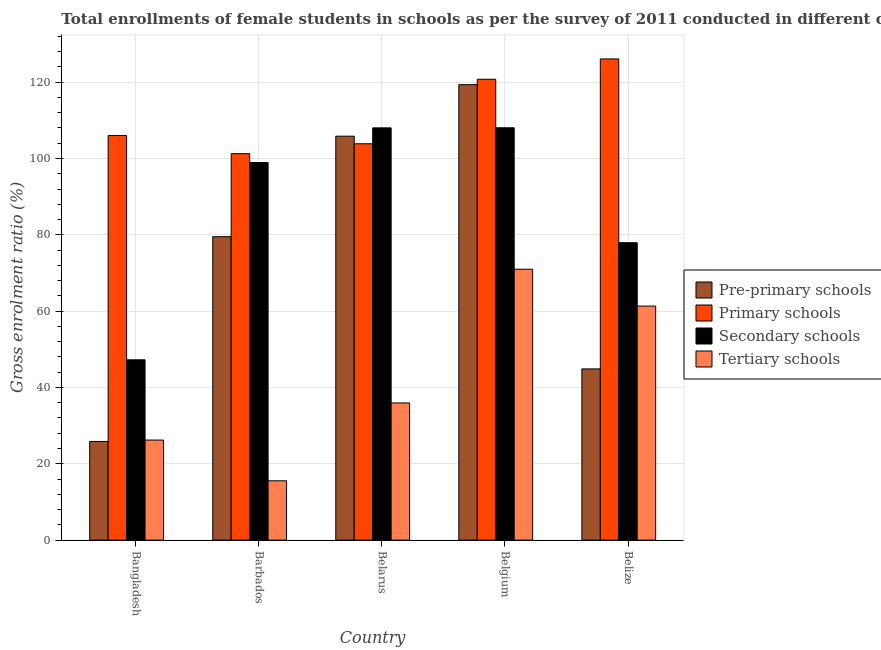Are the number of bars per tick equal to the number of legend labels?
Ensure brevity in your answer.  Yes. What is the label of the 5th group of bars from the left?
Provide a short and direct response. Belize. In how many cases, is the number of bars for a given country not equal to the number of legend labels?
Offer a terse response. 0. What is the gross enrolment ratio(female) in pre-primary schools in Bangladesh?
Give a very brief answer. 25.85. Across all countries, what is the maximum gross enrolment ratio(female) in pre-primary schools?
Keep it short and to the point. 119.34. Across all countries, what is the minimum gross enrolment ratio(female) in tertiary schools?
Provide a succinct answer. 15.54. In which country was the gross enrolment ratio(female) in tertiary schools minimum?
Offer a very short reply. Barbados. What is the total gross enrolment ratio(female) in tertiary schools in the graph?
Provide a succinct answer. 210. What is the difference between the gross enrolment ratio(female) in secondary schools in Barbados and that in Belarus?
Your answer should be very brief. -9.07. What is the difference between the gross enrolment ratio(female) in tertiary schools in Bangladesh and the gross enrolment ratio(female) in pre-primary schools in Belarus?
Your response must be concise. -79.63. What is the average gross enrolment ratio(female) in pre-primary schools per country?
Provide a succinct answer. 75.08. What is the difference between the gross enrolment ratio(female) in tertiary schools and gross enrolment ratio(female) in pre-primary schools in Bangladesh?
Keep it short and to the point. 0.36. What is the ratio of the gross enrolment ratio(female) in secondary schools in Belarus to that in Belgium?
Your response must be concise. 1. What is the difference between the highest and the second highest gross enrolment ratio(female) in tertiary schools?
Your answer should be compact. 9.65. What is the difference between the highest and the lowest gross enrolment ratio(female) in secondary schools?
Offer a very short reply. 60.81. In how many countries, is the gross enrolment ratio(female) in secondary schools greater than the average gross enrolment ratio(female) in secondary schools taken over all countries?
Give a very brief answer. 3. Is the sum of the gross enrolment ratio(female) in tertiary schools in Bangladesh and Belize greater than the maximum gross enrolment ratio(female) in secondary schools across all countries?
Give a very brief answer. No. Is it the case that in every country, the sum of the gross enrolment ratio(female) in pre-primary schools and gross enrolment ratio(female) in primary schools is greater than the sum of gross enrolment ratio(female) in tertiary schools and gross enrolment ratio(female) in secondary schools?
Offer a very short reply. No. What does the 4th bar from the left in Belarus represents?
Offer a terse response. Tertiary schools. What does the 3rd bar from the right in Barbados represents?
Provide a short and direct response. Primary schools. How many bars are there?
Provide a succinct answer. 20. Are all the bars in the graph horizontal?
Your response must be concise. No. What is the difference between two consecutive major ticks on the Y-axis?
Offer a very short reply. 20. How are the legend labels stacked?
Keep it short and to the point. Vertical. What is the title of the graph?
Give a very brief answer. Total enrollments of female students in schools as per the survey of 2011 conducted in different countries. What is the label or title of the X-axis?
Offer a terse response. Country. What is the Gross enrolment ratio (%) in Pre-primary schools in Bangladesh?
Make the answer very short. 25.85. What is the Gross enrolment ratio (%) of Primary schools in Bangladesh?
Your response must be concise. 106.02. What is the Gross enrolment ratio (%) in Secondary schools in Bangladesh?
Ensure brevity in your answer.  47.24. What is the Gross enrolment ratio (%) of Tertiary schools in Bangladesh?
Make the answer very short. 26.21. What is the Gross enrolment ratio (%) in Pre-primary schools in Barbados?
Ensure brevity in your answer.  79.51. What is the Gross enrolment ratio (%) in Primary schools in Barbados?
Your response must be concise. 101.26. What is the Gross enrolment ratio (%) of Secondary schools in Barbados?
Ensure brevity in your answer.  98.95. What is the Gross enrolment ratio (%) of Tertiary schools in Barbados?
Your answer should be very brief. 15.54. What is the Gross enrolment ratio (%) of Pre-primary schools in Belarus?
Your answer should be very brief. 105.85. What is the Gross enrolment ratio (%) of Primary schools in Belarus?
Ensure brevity in your answer.  103.86. What is the Gross enrolment ratio (%) of Secondary schools in Belarus?
Offer a terse response. 108.02. What is the Gross enrolment ratio (%) in Tertiary schools in Belarus?
Provide a succinct answer. 35.94. What is the Gross enrolment ratio (%) of Pre-primary schools in Belgium?
Offer a terse response. 119.34. What is the Gross enrolment ratio (%) in Primary schools in Belgium?
Provide a succinct answer. 120.76. What is the Gross enrolment ratio (%) of Secondary schools in Belgium?
Keep it short and to the point. 108.05. What is the Gross enrolment ratio (%) in Tertiary schools in Belgium?
Provide a short and direct response. 70.98. What is the Gross enrolment ratio (%) in Pre-primary schools in Belize?
Make the answer very short. 44.86. What is the Gross enrolment ratio (%) in Primary schools in Belize?
Provide a short and direct response. 126.09. What is the Gross enrolment ratio (%) of Secondary schools in Belize?
Offer a very short reply. 77.93. What is the Gross enrolment ratio (%) of Tertiary schools in Belize?
Make the answer very short. 61.33. Across all countries, what is the maximum Gross enrolment ratio (%) of Pre-primary schools?
Offer a very short reply. 119.34. Across all countries, what is the maximum Gross enrolment ratio (%) of Primary schools?
Provide a short and direct response. 126.09. Across all countries, what is the maximum Gross enrolment ratio (%) in Secondary schools?
Provide a short and direct response. 108.05. Across all countries, what is the maximum Gross enrolment ratio (%) of Tertiary schools?
Keep it short and to the point. 70.98. Across all countries, what is the minimum Gross enrolment ratio (%) of Pre-primary schools?
Provide a short and direct response. 25.85. Across all countries, what is the minimum Gross enrolment ratio (%) of Primary schools?
Your answer should be compact. 101.26. Across all countries, what is the minimum Gross enrolment ratio (%) in Secondary schools?
Make the answer very short. 47.24. Across all countries, what is the minimum Gross enrolment ratio (%) in Tertiary schools?
Your response must be concise. 15.54. What is the total Gross enrolment ratio (%) in Pre-primary schools in the graph?
Ensure brevity in your answer.  375.41. What is the total Gross enrolment ratio (%) in Primary schools in the graph?
Offer a very short reply. 557.98. What is the total Gross enrolment ratio (%) of Secondary schools in the graph?
Offer a terse response. 440.19. What is the total Gross enrolment ratio (%) in Tertiary schools in the graph?
Your answer should be compact. 210. What is the difference between the Gross enrolment ratio (%) in Pre-primary schools in Bangladesh and that in Barbados?
Give a very brief answer. -53.65. What is the difference between the Gross enrolment ratio (%) in Primary schools in Bangladesh and that in Barbados?
Provide a short and direct response. 4.76. What is the difference between the Gross enrolment ratio (%) of Secondary schools in Bangladesh and that in Barbados?
Give a very brief answer. -51.71. What is the difference between the Gross enrolment ratio (%) in Tertiary schools in Bangladesh and that in Barbados?
Provide a short and direct response. 10.67. What is the difference between the Gross enrolment ratio (%) of Pre-primary schools in Bangladesh and that in Belarus?
Keep it short and to the point. -79.99. What is the difference between the Gross enrolment ratio (%) in Primary schools in Bangladesh and that in Belarus?
Offer a terse response. 2.16. What is the difference between the Gross enrolment ratio (%) of Secondary schools in Bangladesh and that in Belarus?
Offer a terse response. -60.78. What is the difference between the Gross enrolment ratio (%) of Tertiary schools in Bangladesh and that in Belarus?
Keep it short and to the point. -9.73. What is the difference between the Gross enrolment ratio (%) in Pre-primary schools in Bangladesh and that in Belgium?
Your answer should be very brief. -93.49. What is the difference between the Gross enrolment ratio (%) in Primary schools in Bangladesh and that in Belgium?
Provide a succinct answer. -14.75. What is the difference between the Gross enrolment ratio (%) in Secondary schools in Bangladesh and that in Belgium?
Provide a succinct answer. -60.8. What is the difference between the Gross enrolment ratio (%) in Tertiary schools in Bangladesh and that in Belgium?
Your response must be concise. -44.77. What is the difference between the Gross enrolment ratio (%) of Pre-primary schools in Bangladesh and that in Belize?
Give a very brief answer. -19.01. What is the difference between the Gross enrolment ratio (%) in Primary schools in Bangladesh and that in Belize?
Provide a succinct answer. -20.07. What is the difference between the Gross enrolment ratio (%) of Secondary schools in Bangladesh and that in Belize?
Offer a very short reply. -30.68. What is the difference between the Gross enrolment ratio (%) in Tertiary schools in Bangladesh and that in Belize?
Provide a succinct answer. -35.11. What is the difference between the Gross enrolment ratio (%) of Pre-primary schools in Barbados and that in Belarus?
Make the answer very short. -26.34. What is the difference between the Gross enrolment ratio (%) of Primary schools in Barbados and that in Belarus?
Offer a very short reply. -2.59. What is the difference between the Gross enrolment ratio (%) of Secondary schools in Barbados and that in Belarus?
Your answer should be very brief. -9.07. What is the difference between the Gross enrolment ratio (%) of Tertiary schools in Barbados and that in Belarus?
Offer a terse response. -20.4. What is the difference between the Gross enrolment ratio (%) in Pre-primary schools in Barbados and that in Belgium?
Keep it short and to the point. -39.84. What is the difference between the Gross enrolment ratio (%) in Primary schools in Barbados and that in Belgium?
Make the answer very short. -19.5. What is the difference between the Gross enrolment ratio (%) in Secondary schools in Barbados and that in Belgium?
Provide a succinct answer. -9.1. What is the difference between the Gross enrolment ratio (%) of Tertiary schools in Barbados and that in Belgium?
Ensure brevity in your answer.  -55.44. What is the difference between the Gross enrolment ratio (%) in Pre-primary schools in Barbados and that in Belize?
Ensure brevity in your answer.  34.65. What is the difference between the Gross enrolment ratio (%) in Primary schools in Barbados and that in Belize?
Your answer should be very brief. -24.82. What is the difference between the Gross enrolment ratio (%) in Secondary schools in Barbados and that in Belize?
Ensure brevity in your answer.  21.02. What is the difference between the Gross enrolment ratio (%) in Tertiary schools in Barbados and that in Belize?
Keep it short and to the point. -45.79. What is the difference between the Gross enrolment ratio (%) of Pre-primary schools in Belarus and that in Belgium?
Your answer should be compact. -13.5. What is the difference between the Gross enrolment ratio (%) of Primary schools in Belarus and that in Belgium?
Give a very brief answer. -16.91. What is the difference between the Gross enrolment ratio (%) in Secondary schools in Belarus and that in Belgium?
Your response must be concise. -0.02. What is the difference between the Gross enrolment ratio (%) of Tertiary schools in Belarus and that in Belgium?
Provide a succinct answer. -35.04. What is the difference between the Gross enrolment ratio (%) in Pre-primary schools in Belarus and that in Belize?
Your response must be concise. 60.99. What is the difference between the Gross enrolment ratio (%) in Primary schools in Belarus and that in Belize?
Give a very brief answer. -22.23. What is the difference between the Gross enrolment ratio (%) in Secondary schools in Belarus and that in Belize?
Your answer should be very brief. 30.1. What is the difference between the Gross enrolment ratio (%) of Tertiary schools in Belarus and that in Belize?
Keep it short and to the point. -25.39. What is the difference between the Gross enrolment ratio (%) of Pre-primary schools in Belgium and that in Belize?
Ensure brevity in your answer.  74.48. What is the difference between the Gross enrolment ratio (%) of Primary schools in Belgium and that in Belize?
Offer a terse response. -5.32. What is the difference between the Gross enrolment ratio (%) in Secondary schools in Belgium and that in Belize?
Provide a succinct answer. 30.12. What is the difference between the Gross enrolment ratio (%) of Tertiary schools in Belgium and that in Belize?
Make the answer very short. 9.65. What is the difference between the Gross enrolment ratio (%) in Pre-primary schools in Bangladesh and the Gross enrolment ratio (%) in Primary schools in Barbados?
Your answer should be compact. -75.41. What is the difference between the Gross enrolment ratio (%) of Pre-primary schools in Bangladesh and the Gross enrolment ratio (%) of Secondary schools in Barbados?
Ensure brevity in your answer.  -73.1. What is the difference between the Gross enrolment ratio (%) in Pre-primary schools in Bangladesh and the Gross enrolment ratio (%) in Tertiary schools in Barbados?
Offer a terse response. 10.31. What is the difference between the Gross enrolment ratio (%) in Primary schools in Bangladesh and the Gross enrolment ratio (%) in Secondary schools in Barbados?
Offer a very short reply. 7.07. What is the difference between the Gross enrolment ratio (%) in Primary schools in Bangladesh and the Gross enrolment ratio (%) in Tertiary schools in Barbados?
Keep it short and to the point. 90.48. What is the difference between the Gross enrolment ratio (%) in Secondary schools in Bangladesh and the Gross enrolment ratio (%) in Tertiary schools in Barbados?
Your answer should be very brief. 31.7. What is the difference between the Gross enrolment ratio (%) in Pre-primary schools in Bangladesh and the Gross enrolment ratio (%) in Primary schools in Belarus?
Ensure brevity in your answer.  -78. What is the difference between the Gross enrolment ratio (%) of Pre-primary schools in Bangladesh and the Gross enrolment ratio (%) of Secondary schools in Belarus?
Offer a terse response. -82.17. What is the difference between the Gross enrolment ratio (%) in Pre-primary schools in Bangladesh and the Gross enrolment ratio (%) in Tertiary schools in Belarus?
Your answer should be compact. -10.09. What is the difference between the Gross enrolment ratio (%) of Primary schools in Bangladesh and the Gross enrolment ratio (%) of Secondary schools in Belarus?
Your response must be concise. -2.01. What is the difference between the Gross enrolment ratio (%) in Primary schools in Bangladesh and the Gross enrolment ratio (%) in Tertiary schools in Belarus?
Give a very brief answer. 70.08. What is the difference between the Gross enrolment ratio (%) of Secondary schools in Bangladesh and the Gross enrolment ratio (%) of Tertiary schools in Belarus?
Ensure brevity in your answer.  11.3. What is the difference between the Gross enrolment ratio (%) of Pre-primary schools in Bangladesh and the Gross enrolment ratio (%) of Primary schools in Belgium?
Provide a succinct answer. -94.91. What is the difference between the Gross enrolment ratio (%) of Pre-primary schools in Bangladesh and the Gross enrolment ratio (%) of Secondary schools in Belgium?
Your response must be concise. -82.2. What is the difference between the Gross enrolment ratio (%) of Pre-primary schools in Bangladesh and the Gross enrolment ratio (%) of Tertiary schools in Belgium?
Give a very brief answer. -45.13. What is the difference between the Gross enrolment ratio (%) in Primary schools in Bangladesh and the Gross enrolment ratio (%) in Secondary schools in Belgium?
Keep it short and to the point. -2.03. What is the difference between the Gross enrolment ratio (%) of Primary schools in Bangladesh and the Gross enrolment ratio (%) of Tertiary schools in Belgium?
Ensure brevity in your answer.  35.04. What is the difference between the Gross enrolment ratio (%) of Secondary schools in Bangladesh and the Gross enrolment ratio (%) of Tertiary schools in Belgium?
Your response must be concise. -23.74. What is the difference between the Gross enrolment ratio (%) of Pre-primary schools in Bangladesh and the Gross enrolment ratio (%) of Primary schools in Belize?
Offer a very short reply. -100.23. What is the difference between the Gross enrolment ratio (%) of Pre-primary schools in Bangladesh and the Gross enrolment ratio (%) of Secondary schools in Belize?
Ensure brevity in your answer.  -52.07. What is the difference between the Gross enrolment ratio (%) of Pre-primary schools in Bangladesh and the Gross enrolment ratio (%) of Tertiary schools in Belize?
Provide a succinct answer. -35.47. What is the difference between the Gross enrolment ratio (%) in Primary schools in Bangladesh and the Gross enrolment ratio (%) in Secondary schools in Belize?
Your response must be concise. 28.09. What is the difference between the Gross enrolment ratio (%) in Primary schools in Bangladesh and the Gross enrolment ratio (%) in Tertiary schools in Belize?
Offer a very short reply. 44.69. What is the difference between the Gross enrolment ratio (%) of Secondary schools in Bangladesh and the Gross enrolment ratio (%) of Tertiary schools in Belize?
Give a very brief answer. -14.08. What is the difference between the Gross enrolment ratio (%) in Pre-primary schools in Barbados and the Gross enrolment ratio (%) in Primary schools in Belarus?
Provide a short and direct response. -24.35. What is the difference between the Gross enrolment ratio (%) in Pre-primary schools in Barbados and the Gross enrolment ratio (%) in Secondary schools in Belarus?
Provide a short and direct response. -28.52. What is the difference between the Gross enrolment ratio (%) in Pre-primary schools in Barbados and the Gross enrolment ratio (%) in Tertiary schools in Belarus?
Provide a short and direct response. 43.57. What is the difference between the Gross enrolment ratio (%) of Primary schools in Barbados and the Gross enrolment ratio (%) of Secondary schools in Belarus?
Provide a short and direct response. -6.76. What is the difference between the Gross enrolment ratio (%) of Primary schools in Barbados and the Gross enrolment ratio (%) of Tertiary schools in Belarus?
Provide a succinct answer. 65.32. What is the difference between the Gross enrolment ratio (%) in Secondary schools in Barbados and the Gross enrolment ratio (%) in Tertiary schools in Belarus?
Keep it short and to the point. 63.01. What is the difference between the Gross enrolment ratio (%) of Pre-primary schools in Barbados and the Gross enrolment ratio (%) of Primary schools in Belgium?
Provide a short and direct response. -41.26. What is the difference between the Gross enrolment ratio (%) of Pre-primary schools in Barbados and the Gross enrolment ratio (%) of Secondary schools in Belgium?
Your answer should be compact. -28.54. What is the difference between the Gross enrolment ratio (%) in Pre-primary schools in Barbados and the Gross enrolment ratio (%) in Tertiary schools in Belgium?
Your answer should be compact. 8.53. What is the difference between the Gross enrolment ratio (%) of Primary schools in Barbados and the Gross enrolment ratio (%) of Secondary schools in Belgium?
Give a very brief answer. -6.79. What is the difference between the Gross enrolment ratio (%) in Primary schools in Barbados and the Gross enrolment ratio (%) in Tertiary schools in Belgium?
Your response must be concise. 30.28. What is the difference between the Gross enrolment ratio (%) of Secondary schools in Barbados and the Gross enrolment ratio (%) of Tertiary schools in Belgium?
Offer a terse response. 27.97. What is the difference between the Gross enrolment ratio (%) of Pre-primary schools in Barbados and the Gross enrolment ratio (%) of Primary schools in Belize?
Provide a short and direct response. -46.58. What is the difference between the Gross enrolment ratio (%) in Pre-primary schools in Barbados and the Gross enrolment ratio (%) in Secondary schools in Belize?
Give a very brief answer. 1.58. What is the difference between the Gross enrolment ratio (%) of Pre-primary schools in Barbados and the Gross enrolment ratio (%) of Tertiary schools in Belize?
Offer a very short reply. 18.18. What is the difference between the Gross enrolment ratio (%) in Primary schools in Barbados and the Gross enrolment ratio (%) in Secondary schools in Belize?
Your answer should be compact. 23.33. What is the difference between the Gross enrolment ratio (%) of Primary schools in Barbados and the Gross enrolment ratio (%) of Tertiary schools in Belize?
Offer a terse response. 39.94. What is the difference between the Gross enrolment ratio (%) in Secondary schools in Barbados and the Gross enrolment ratio (%) in Tertiary schools in Belize?
Your answer should be very brief. 37.62. What is the difference between the Gross enrolment ratio (%) in Pre-primary schools in Belarus and the Gross enrolment ratio (%) in Primary schools in Belgium?
Ensure brevity in your answer.  -14.92. What is the difference between the Gross enrolment ratio (%) in Pre-primary schools in Belarus and the Gross enrolment ratio (%) in Secondary schools in Belgium?
Make the answer very short. -2.2. What is the difference between the Gross enrolment ratio (%) in Pre-primary schools in Belarus and the Gross enrolment ratio (%) in Tertiary schools in Belgium?
Give a very brief answer. 34.87. What is the difference between the Gross enrolment ratio (%) of Primary schools in Belarus and the Gross enrolment ratio (%) of Secondary schools in Belgium?
Make the answer very short. -4.19. What is the difference between the Gross enrolment ratio (%) in Primary schools in Belarus and the Gross enrolment ratio (%) in Tertiary schools in Belgium?
Provide a short and direct response. 32.88. What is the difference between the Gross enrolment ratio (%) in Secondary schools in Belarus and the Gross enrolment ratio (%) in Tertiary schools in Belgium?
Offer a very short reply. 37.04. What is the difference between the Gross enrolment ratio (%) in Pre-primary schools in Belarus and the Gross enrolment ratio (%) in Primary schools in Belize?
Your answer should be very brief. -20.24. What is the difference between the Gross enrolment ratio (%) in Pre-primary schools in Belarus and the Gross enrolment ratio (%) in Secondary schools in Belize?
Ensure brevity in your answer.  27.92. What is the difference between the Gross enrolment ratio (%) of Pre-primary schools in Belarus and the Gross enrolment ratio (%) of Tertiary schools in Belize?
Provide a short and direct response. 44.52. What is the difference between the Gross enrolment ratio (%) in Primary schools in Belarus and the Gross enrolment ratio (%) in Secondary schools in Belize?
Ensure brevity in your answer.  25.93. What is the difference between the Gross enrolment ratio (%) of Primary schools in Belarus and the Gross enrolment ratio (%) of Tertiary schools in Belize?
Make the answer very short. 42.53. What is the difference between the Gross enrolment ratio (%) in Secondary schools in Belarus and the Gross enrolment ratio (%) in Tertiary schools in Belize?
Provide a short and direct response. 46.7. What is the difference between the Gross enrolment ratio (%) of Pre-primary schools in Belgium and the Gross enrolment ratio (%) of Primary schools in Belize?
Offer a terse response. -6.74. What is the difference between the Gross enrolment ratio (%) in Pre-primary schools in Belgium and the Gross enrolment ratio (%) in Secondary schools in Belize?
Offer a very short reply. 41.42. What is the difference between the Gross enrolment ratio (%) in Pre-primary schools in Belgium and the Gross enrolment ratio (%) in Tertiary schools in Belize?
Give a very brief answer. 58.02. What is the difference between the Gross enrolment ratio (%) in Primary schools in Belgium and the Gross enrolment ratio (%) in Secondary schools in Belize?
Ensure brevity in your answer.  42.84. What is the difference between the Gross enrolment ratio (%) of Primary schools in Belgium and the Gross enrolment ratio (%) of Tertiary schools in Belize?
Offer a terse response. 59.44. What is the difference between the Gross enrolment ratio (%) in Secondary schools in Belgium and the Gross enrolment ratio (%) in Tertiary schools in Belize?
Give a very brief answer. 46.72. What is the average Gross enrolment ratio (%) in Pre-primary schools per country?
Offer a terse response. 75.08. What is the average Gross enrolment ratio (%) of Primary schools per country?
Offer a very short reply. 111.6. What is the average Gross enrolment ratio (%) in Secondary schools per country?
Offer a very short reply. 88.04. What is the average Gross enrolment ratio (%) of Tertiary schools per country?
Ensure brevity in your answer.  42. What is the difference between the Gross enrolment ratio (%) of Pre-primary schools and Gross enrolment ratio (%) of Primary schools in Bangladesh?
Your answer should be compact. -80.16. What is the difference between the Gross enrolment ratio (%) of Pre-primary schools and Gross enrolment ratio (%) of Secondary schools in Bangladesh?
Make the answer very short. -21.39. What is the difference between the Gross enrolment ratio (%) in Pre-primary schools and Gross enrolment ratio (%) in Tertiary schools in Bangladesh?
Your answer should be compact. -0.36. What is the difference between the Gross enrolment ratio (%) of Primary schools and Gross enrolment ratio (%) of Secondary schools in Bangladesh?
Keep it short and to the point. 58.77. What is the difference between the Gross enrolment ratio (%) of Primary schools and Gross enrolment ratio (%) of Tertiary schools in Bangladesh?
Provide a short and direct response. 79.8. What is the difference between the Gross enrolment ratio (%) in Secondary schools and Gross enrolment ratio (%) in Tertiary schools in Bangladesh?
Offer a very short reply. 21.03. What is the difference between the Gross enrolment ratio (%) of Pre-primary schools and Gross enrolment ratio (%) of Primary schools in Barbados?
Provide a short and direct response. -21.75. What is the difference between the Gross enrolment ratio (%) of Pre-primary schools and Gross enrolment ratio (%) of Secondary schools in Barbados?
Keep it short and to the point. -19.44. What is the difference between the Gross enrolment ratio (%) in Pre-primary schools and Gross enrolment ratio (%) in Tertiary schools in Barbados?
Ensure brevity in your answer.  63.97. What is the difference between the Gross enrolment ratio (%) of Primary schools and Gross enrolment ratio (%) of Secondary schools in Barbados?
Give a very brief answer. 2.31. What is the difference between the Gross enrolment ratio (%) of Primary schools and Gross enrolment ratio (%) of Tertiary schools in Barbados?
Your answer should be compact. 85.72. What is the difference between the Gross enrolment ratio (%) in Secondary schools and Gross enrolment ratio (%) in Tertiary schools in Barbados?
Give a very brief answer. 83.41. What is the difference between the Gross enrolment ratio (%) of Pre-primary schools and Gross enrolment ratio (%) of Primary schools in Belarus?
Provide a succinct answer. 1.99. What is the difference between the Gross enrolment ratio (%) in Pre-primary schools and Gross enrolment ratio (%) in Secondary schools in Belarus?
Your response must be concise. -2.18. What is the difference between the Gross enrolment ratio (%) of Pre-primary schools and Gross enrolment ratio (%) of Tertiary schools in Belarus?
Your answer should be very brief. 69.91. What is the difference between the Gross enrolment ratio (%) of Primary schools and Gross enrolment ratio (%) of Secondary schools in Belarus?
Your answer should be compact. -4.17. What is the difference between the Gross enrolment ratio (%) of Primary schools and Gross enrolment ratio (%) of Tertiary schools in Belarus?
Your answer should be compact. 67.92. What is the difference between the Gross enrolment ratio (%) of Secondary schools and Gross enrolment ratio (%) of Tertiary schools in Belarus?
Your answer should be very brief. 72.08. What is the difference between the Gross enrolment ratio (%) of Pre-primary schools and Gross enrolment ratio (%) of Primary schools in Belgium?
Give a very brief answer. -1.42. What is the difference between the Gross enrolment ratio (%) of Pre-primary schools and Gross enrolment ratio (%) of Secondary schools in Belgium?
Provide a succinct answer. 11.3. What is the difference between the Gross enrolment ratio (%) of Pre-primary schools and Gross enrolment ratio (%) of Tertiary schools in Belgium?
Give a very brief answer. 48.37. What is the difference between the Gross enrolment ratio (%) of Primary schools and Gross enrolment ratio (%) of Secondary schools in Belgium?
Provide a succinct answer. 12.72. What is the difference between the Gross enrolment ratio (%) of Primary schools and Gross enrolment ratio (%) of Tertiary schools in Belgium?
Keep it short and to the point. 49.78. What is the difference between the Gross enrolment ratio (%) of Secondary schools and Gross enrolment ratio (%) of Tertiary schools in Belgium?
Provide a succinct answer. 37.07. What is the difference between the Gross enrolment ratio (%) in Pre-primary schools and Gross enrolment ratio (%) in Primary schools in Belize?
Ensure brevity in your answer.  -81.23. What is the difference between the Gross enrolment ratio (%) in Pre-primary schools and Gross enrolment ratio (%) in Secondary schools in Belize?
Provide a short and direct response. -33.07. What is the difference between the Gross enrolment ratio (%) in Pre-primary schools and Gross enrolment ratio (%) in Tertiary schools in Belize?
Offer a very short reply. -16.47. What is the difference between the Gross enrolment ratio (%) in Primary schools and Gross enrolment ratio (%) in Secondary schools in Belize?
Keep it short and to the point. 48.16. What is the difference between the Gross enrolment ratio (%) in Primary schools and Gross enrolment ratio (%) in Tertiary schools in Belize?
Provide a succinct answer. 64.76. What is the difference between the Gross enrolment ratio (%) in Secondary schools and Gross enrolment ratio (%) in Tertiary schools in Belize?
Offer a terse response. 16.6. What is the ratio of the Gross enrolment ratio (%) of Pre-primary schools in Bangladesh to that in Barbados?
Ensure brevity in your answer.  0.33. What is the ratio of the Gross enrolment ratio (%) in Primary schools in Bangladesh to that in Barbados?
Your response must be concise. 1.05. What is the ratio of the Gross enrolment ratio (%) of Secondary schools in Bangladesh to that in Barbados?
Offer a very short reply. 0.48. What is the ratio of the Gross enrolment ratio (%) of Tertiary schools in Bangladesh to that in Barbados?
Make the answer very short. 1.69. What is the ratio of the Gross enrolment ratio (%) in Pre-primary schools in Bangladesh to that in Belarus?
Give a very brief answer. 0.24. What is the ratio of the Gross enrolment ratio (%) in Primary schools in Bangladesh to that in Belarus?
Ensure brevity in your answer.  1.02. What is the ratio of the Gross enrolment ratio (%) in Secondary schools in Bangladesh to that in Belarus?
Your response must be concise. 0.44. What is the ratio of the Gross enrolment ratio (%) of Tertiary schools in Bangladesh to that in Belarus?
Make the answer very short. 0.73. What is the ratio of the Gross enrolment ratio (%) in Pre-primary schools in Bangladesh to that in Belgium?
Provide a succinct answer. 0.22. What is the ratio of the Gross enrolment ratio (%) of Primary schools in Bangladesh to that in Belgium?
Provide a succinct answer. 0.88. What is the ratio of the Gross enrolment ratio (%) of Secondary schools in Bangladesh to that in Belgium?
Your answer should be compact. 0.44. What is the ratio of the Gross enrolment ratio (%) in Tertiary schools in Bangladesh to that in Belgium?
Give a very brief answer. 0.37. What is the ratio of the Gross enrolment ratio (%) of Pre-primary schools in Bangladesh to that in Belize?
Make the answer very short. 0.58. What is the ratio of the Gross enrolment ratio (%) of Primary schools in Bangladesh to that in Belize?
Provide a succinct answer. 0.84. What is the ratio of the Gross enrolment ratio (%) of Secondary schools in Bangladesh to that in Belize?
Keep it short and to the point. 0.61. What is the ratio of the Gross enrolment ratio (%) of Tertiary schools in Bangladesh to that in Belize?
Ensure brevity in your answer.  0.43. What is the ratio of the Gross enrolment ratio (%) in Pre-primary schools in Barbados to that in Belarus?
Provide a short and direct response. 0.75. What is the ratio of the Gross enrolment ratio (%) in Primary schools in Barbados to that in Belarus?
Your response must be concise. 0.97. What is the ratio of the Gross enrolment ratio (%) of Secondary schools in Barbados to that in Belarus?
Ensure brevity in your answer.  0.92. What is the ratio of the Gross enrolment ratio (%) in Tertiary schools in Barbados to that in Belarus?
Give a very brief answer. 0.43. What is the ratio of the Gross enrolment ratio (%) in Pre-primary schools in Barbados to that in Belgium?
Give a very brief answer. 0.67. What is the ratio of the Gross enrolment ratio (%) of Primary schools in Barbados to that in Belgium?
Ensure brevity in your answer.  0.84. What is the ratio of the Gross enrolment ratio (%) of Secondary schools in Barbados to that in Belgium?
Give a very brief answer. 0.92. What is the ratio of the Gross enrolment ratio (%) in Tertiary schools in Barbados to that in Belgium?
Offer a terse response. 0.22. What is the ratio of the Gross enrolment ratio (%) of Pre-primary schools in Barbados to that in Belize?
Provide a short and direct response. 1.77. What is the ratio of the Gross enrolment ratio (%) in Primary schools in Barbados to that in Belize?
Make the answer very short. 0.8. What is the ratio of the Gross enrolment ratio (%) in Secondary schools in Barbados to that in Belize?
Make the answer very short. 1.27. What is the ratio of the Gross enrolment ratio (%) in Tertiary schools in Barbados to that in Belize?
Your answer should be very brief. 0.25. What is the ratio of the Gross enrolment ratio (%) in Pre-primary schools in Belarus to that in Belgium?
Provide a short and direct response. 0.89. What is the ratio of the Gross enrolment ratio (%) in Primary schools in Belarus to that in Belgium?
Ensure brevity in your answer.  0.86. What is the ratio of the Gross enrolment ratio (%) in Secondary schools in Belarus to that in Belgium?
Make the answer very short. 1. What is the ratio of the Gross enrolment ratio (%) in Tertiary schools in Belarus to that in Belgium?
Your answer should be compact. 0.51. What is the ratio of the Gross enrolment ratio (%) of Pre-primary schools in Belarus to that in Belize?
Give a very brief answer. 2.36. What is the ratio of the Gross enrolment ratio (%) of Primary schools in Belarus to that in Belize?
Your answer should be very brief. 0.82. What is the ratio of the Gross enrolment ratio (%) in Secondary schools in Belarus to that in Belize?
Ensure brevity in your answer.  1.39. What is the ratio of the Gross enrolment ratio (%) of Tertiary schools in Belarus to that in Belize?
Ensure brevity in your answer.  0.59. What is the ratio of the Gross enrolment ratio (%) in Pre-primary schools in Belgium to that in Belize?
Offer a very short reply. 2.66. What is the ratio of the Gross enrolment ratio (%) of Primary schools in Belgium to that in Belize?
Your answer should be compact. 0.96. What is the ratio of the Gross enrolment ratio (%) in Secondary schools in Belgium to that in Belize?
Ensure brevity in your answer.  1.39. What is the ratio of the Gross enrolment ratio (%) of Tertiary schools in Belgium to that in Belize?
Your response must be concise. 1.16. What is the difference between the highest and the second highest Gross enrolment ratio (%) in Pre-primary schools?
Your response must be concise. 13.5. What is the difference between the highest and the second highest Gross enrolment ratio (%) in Primary schools?
Ensure brevity in your answer.  5.32. What is the difference between the highest and the second highest Gross enrolment ratio (%) of Secondary schools?
Offer a terse response. 0.02. What is the difference between the highest and the second highest Gross enrolment ratio (%) of Tertiary schools?
Ensure brevity in your answer.  9.65. What is the difference between the highest and the lowest Gross enrolment ratio (%) in Pre-primary schools?
Ensure brevity in your answer.  93.49. What is the difference between the highest and the lowest Gross enrolment ratio (%) in Primary schools?
Provide a succinct answer. 24.82. What is the difference between the highest and the lowest Gross enrolment ratio (%) of Secondary schools?
Give a very brief answer. 60.8. What is the difference between the highest and the lowest Gross enrolment ratio (%) in Tertiary schools?
Your response must be concise. 55.44. 